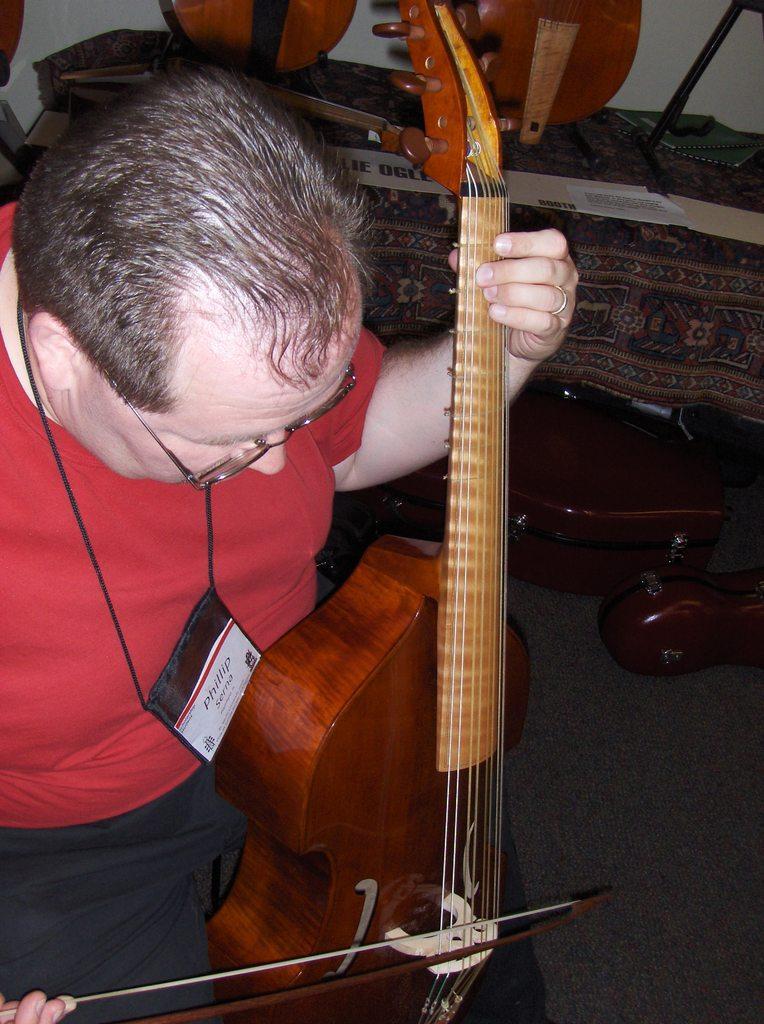How would you summarize this image in a sentence or two? In the foreground of the pictures there is a person in red dress playing a musical instrument. In the center of the picture there are musical instruments and a table covered with cloth. 